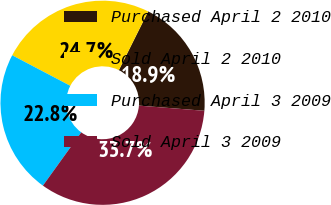<chart> <loc_0><loc_0><loc_500><loc_500><pie_chart><fcel>Purchased April 2 2010<fcel>Sold April 2 2010<fcel>Purchased April 3 2009<fcel>Sold April 3 2009<nl><fcel>18.88%<fcel>24.67%<fcel>22.77%<fcel>33.68%<nl></chart> 